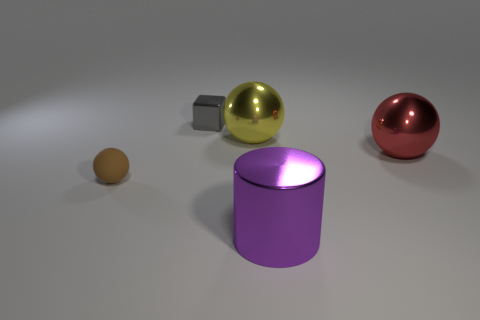Add 1 large green metal spheres. How many objects exist? 6 Subtract all green balls. Subtract all yellow cylinders. How many balls are left? 3 Subtract all cylinders. How many objects are left? 4 Subtract 0 red cylinders. How many objects are left? 5 Subtract all big metal things. Subtract all large purple metal objects. How many objects are left? 1 Add 4 big red metal spheres. How many big red metal spheres are left? 5 Add 4 big cylinders. How many big cylinders exist? 5 